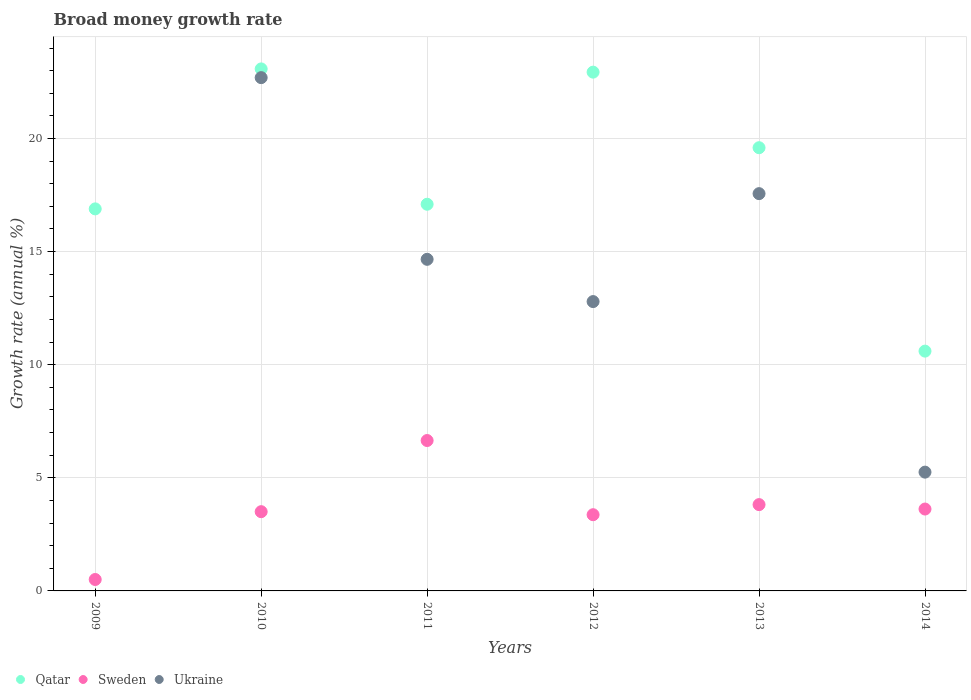What is the growth rate in Qatar in 2009?
Ensure brevity in your answer.  16.89. Across all years, what is the maximum growth rate in Sweden?
Keep it short and to the point. 6.65. Across all years, what is the minimum growth rate in Qatar?
Make the answer very short. 10.6. What is the total growth rate in Qatar in the graph?
Ensure brevity in your answer.  110.19. What is the difference between the growth rate in Sweden in 2010 and that in 2014?
Your response must be concise. -0.12. What is the difference between the growth rate in Ukraine in 2009 and the growth rate in Qatar in 2010?
Your response must be concise. -23.08. What is the average growth rate in Sweden per year?
Ensure brevity in your answer.  3.58. In the year 2010, what is the difference between the growth rate in Sweden and growth rate in Ukraine?
Your answer should be compact. -19.19. What is the ratio of the growth rate in Qatar in 2011 to that in 2013?
Your response must be concise. 0.87. What is the difference between the highest and the second highest growth rate in Qatar?
Your answer should be very brief. 0.14. What is the difference between the highest and the lowest growth rate in Qatar?
Ensure brevity in your answer.  12.48. In how many years, is the growth rate in Sweden greater than the average growth rate in Sweden taken over all years?
Your answer should be compact. 3. Is the sum of the growth rate in Sweden in 2010 and 2011 greater than the maximum growth rate in Ukraine across all years?
Offer a very short reply. No. Is the growth rate in Sweden strictly less than the growth rate in Ukraine over the years?
Ensure brevity in your answer.  No. Where does the legend appear in the graph?
Keep it short and to the point. Bottom left. How are the legend labels stacked?
Provide a short and direct response. Horizontal. What is the title of the graph?
Keep it short and to the point. Broad money growth rate. What is the label or title of the X-axis?
Ensure brevity in your answer.  Years. What is the label or title of the Y-axis?
Ensure brevity in your answer.  Growth rate (annual %). What is the Growth rate (annual %) of Qatar in 2009?
Offer a terse response. 16.89. What is the Growth rate (annual %) of Sweden in 2009?
Provide a short and direct response. 0.51. What is the Growth rate (annual %) in Qatar in 2010?
Provide a short and direct response. 23.08. What is the Growth rate (annual %) of Sweden in 2010?
Ensure brevity in your answer.  3.5. What is the Growth rate (annual %) in Ukraine in 2010?
Your response must be concise. 22.69. What is the Growth rate (annual %) in Qatar in 2011?
Your answer should be compact. 17.09. What is the Growth rate (annual %) in Sweden in 2011?
Provide a succinct answer. 6.65. What is the Growth rate (annual %) in Ukraine in 2011?
Your answer should be very brief. 14.66. What is the Growth rate (annual %) of Qatar in 2012?
Your response must be concise. 22.93. What is the Growth rate (annual %) in Sweden in 2012?
Your answer should be very brief. 3.37. What is the Growth rate (annual %) of Ukraine in 2012?
Provide a succinct answer. 12.79. What is the Growth rate (annual %) in Qatar in 2013?
Offer a terse response. 19.59. What is the Growth rate (annual %) in Sweden in 2013?
Your response must be concise. 3.82. What is the Growth rate (annual %) in Ukraine in 2013?
Your response must be concise. 17.56. What is the Growth rate (annual %) in Qatar in 2014?
Your response must be concise. 10.6. What is the Growth rate (annual %) of Sweden in 2014?
Ensure brevity in your answer.  3.62. What is the Growth rate (annual %) of Ukraine in 2014?
Provide a short and direct response. 5.25. Across all years, what is the maximum Growth rate (annual %) of Qatar?
Provide a short and direct response. 23.08. Across all years, what is the maximum Growth rate (annual %) in Sweden?
Make the answer very short. 6.65. Across all years, what is the maximum Growth rate (annual %) of Ukraine?
Offer a terse response. 22.69. Across all years, what is the minimum Growth rate (annual %) of Qatar?
Your answer should be very brief. 10.6. Across all years, what is the minimum Growth rate (annual %) in Sweden?
Your answer should be compact. 0.51. Across all years, what is the minimum Growth rate (annual %) of Ukraine?
Your answer should be very brief. 0. What is the total Growth rate (annual %) in Qatar in the graph?
Keep it short and to the point. 110.19. What is the total Growth rate (annual %) in Sweden in the graph?
Make the answer very short. 21.46. What is the total Growth rate (annual %) in Ukraine in the graph?
Ensure brevity in your answer.  72.96. What is the difference between the Growth rate (annual %) in Qatar in 2009 and that in 2010?
Keep it short and to the point. -6.19. What is the difference between the Growth rate (annual %) of Sweden in 2009 and that in 2010?
Your answer should be compact. -3. What is the difference between the Growth rate (annual %) of Qatar in 2009 and that in 2011?
Ensure brevity in your answer.  -0.2. What is the difference between the Growth rate (annual %) in Sweden in 2009 and that in 2011?
Your answer should be compact. -6.14. What is the difference between the Growth rate (annual %) of Qatar in 2009 and that in 2012?
Ensure brevity in your answer.  -6.04. What is the difference between the Growth rate (annual %) in Sweden in 2009 and that in 2012?
Keep it short and to the point. -2.86. What is the difference between the Growth rate (annual %) in Qatar in 2009 and that in 2013?
Make the answer very short. -2.7. What is the difference between the Growth rate (annual %) in Sweden in 2009 and that in 2013?
Offer a terse response. -3.31. What is the difference between the Growth rate (annual %) in Qatar in 2009 and that in 2014?
Provide a succinct answer. 6.29. What is the difference between the Growth rate (annual %) in Sweden in 2009 and that in 2014?
Your answer should be compact. -3.11. What is the difference between the Growth rate (annual %) in Qatar in 2010 and that in 2011?
Give a very brief answer. 5.98. What is the difference between the Growth rate (annual %) in Sweden in 2010 and that in 2011?
Provide a succinct answer. -3.15. What is the difference between the Growth rate (annual %) in Ukraine in 2010 and that in 2011?
Offer a very short reply. 8.03. What is the difference between the Growth rate (annual %) of Qatar in 2010 and that in 2012?
Offer a terse response. 0.14. What is the difference between the Growth rate (annual %) in Sweden in 2010 and that in 2012?
Make the answer very short. 0.13. What is the difference between the Growth rate (annual %) of Ukraine in 2010 and that in 2012?
Provide a succinct answer. 9.9. What is the difference between the Growth rate (annual %) in Qatar in 2010 and that in 2013?
Offer a terse response. 3.48. What is the difference between the Growth rate (annual %) of Sweden in 2010 and that in 2013?
Your answer should be compact. -0.31. What is the difference between the Growth rate (annual %) in Ukraine in 2010 and that in 2013?
Ensure brevity in your answer.  5.13. What is the difference between the Growth rate (annual %) of Qatar in 2010 and that in 2014?
Give a very brief answer. 12.48. What is the difference between the Growth rate (annual %) of Sweden in 2010 and that in 2014?
Your response must be concise. -0.12. What is the difference between the Growth rate (annual %) in Ukraine in 2010 and that in 2014?
Give a very brief answer. 17.44. What is the difference between the Growth rate (annual %) of Qatar in 2011 and that in 2012?
Give a very brief answer. -5.84. What is the difference between the Growth rate (annual %) of Sweden in 2011 and that in 2012?
Your response must be concise. 3.28. What is the difference between the Growth rate (annual %) of Ukraine in 2011 and that in 2012?
Your answer should be very brief. 1.87. What is the difference between the Growth rate (annual %) in Qatar in 2011 and that in 2013?
Keep it short and to the point. -2.5. What is the difference between the Growth rate (annual %) of Sweden in 2011 and that in 2013?
Offer a very short reply. 2.83. What is the difference between the Growth rate (annual %) in Ukraine in 2011 and that in 2013?
Your response must be concise. -2.9. What is the difference between the Growth rate (annual %) in Qatar in 2011 and that in 2014?
Offer a terse response. 6.49. What is the difference between the Growth rate (annual %) of Sweden in 2011 and that in 2014?
Your response must be concise. 3.03. What is the difference between the Growth rate (annual %) in Ukraine in 2011 and that in 2014?
Keep it short and to the point. 9.41. What is the difference between the Growth rate (annual %) in Qatar in 2012 and that in 2013?
Provide a succinct answer. 3.34. What is the difference between the Growth rate (annual %) in Sweden in 2012 and that in 2013?
Keep it short and to the point. -0.45. What is the difference between the Growth rate (annual %) of Ukraine in 2012 and that in 2013?
Ensure brevity in your answer.  -4.77. What is the difference between the Growth rate (annual %) of Qatar in 2012 and that in 2014?
Make the answer very short. 12.33. What is the difference between the Growth rate (annual %) of Sweden in 2012 and that in 2014?
Your response must be concise. -0.25. What is the difference between the Growth rate (annual %) in Ukraine in 2012 and that in 2014?
Provide a succinct answer. 7.54. What is the difference between the Growth rate (annual %) of Qatar in 2013 and that in 2014?
Give a very brief answer. 8.99. What is the difference between the Growth rate (annual %) of Sweden in 2013 and that in 2014?
Provide a succinct answer. 0.2. What is the difference between the Growth rate (annual %) of Ukraine in 2013 and that in 2014?
Your answer should be very brief. 12.31. What is the difference between the Growth rate (annual %) in Qatar in 2009 and the Growth rate (annual %) in Sweden in 2010?
Offer a terse response. 13.39. What is the difference between the Growth rate (annual %) of Qatar in 2009 and the Growth rate (annual %) of Ukraine in 2010?
Your answer should be very brief. -5.8. What is the difference between the Growth rate (annual %) of Sweden in 2009 and the Growth rate (annual %) of Ukraine in 2010?
Keep it short and to the point. -22.19. What is the difference between the Growth rate (annual %) of Qatar in 2009 and the Growth rate (annual %) of Sweden in 2011?
Provide a succinct answer. 10.24. What is the difference between the Growth rate (annual %) of Qatar in 2009 and the Growth rate (annual %) of Ukraine in 2011?
Give a very brief answer. 2.23. What is the difference between the Growth rate (annual %) in Sweden in 2009 and the Growth rate (annual %) in Ukraine in 2011?
Ensure brevity in your answer.  -14.15. What is the difference between the Growth rate (annual %) in Qatar in 2009 and the Growth rate (annual %) in Sweden in 2012?
Your answer should be very brief. 13.52. What is the difference between the Growth rate (annual %) in Qatar in 2009 and the Growth rate (annual %) in Ukraine in 2012?
Ensure brevity in your answer.  4.1. What is the difference between the Growth rate (annual %) of Sweden in 2009 and the Growth rate (annual %) of Ukraine in 2012?
Provide a succinct answer. -12.29. What is the difference between the Growth rate (annual %) in Qatar in 2009 and the Growth rate (annual %) in Sweden in 2013?
Offer a very short reply. 13.07. What is the difference between the Growth rate (annual %) in Qatar in 2009 and the Growth rate (annual %) in Ukraine in 2013?
Offer a very short reply. -0.67. What is the difference between the Growth rate (annual %) in Sweden in 2009 and the Growth rate (annual %) in Ukraine in 2013?
Keep it short and to the point. -17.06. What is the difference between the Growth rate (annual %) of Qatar in 2009 and the Growth rate (annual %) of Sweden in 2014?
Your answer should be compact. 13.27. What is the difference between the Growth rate (annual %) of Qatar in 2009 and the Growth rate (annual %) of Ukraine in 2014?
Provide a short and direct response. 11.64. What is the difference between the Growth rate (annual %) of Sweden in 2009 and the Growth rate (annual %) of Ukraine in 2014?
Offer a very short reply. -4.75. What is the difference between the Growth rate (annual %) of Qatar in 2010 and the Growth rate (annual %) of Sweden in 2011?
Offer a very short reply. 16.43. What is the difference between the Growth rate (annual %) of Qatar in 2010 and the Growth rate (annual %) of Ukraine in 2011?
Keep it short and to the point. 8.42. What is the difference between the Growth rate (annual %) in Sweden in 2010 and the Growth rate (annual %) in Ukraine in 2011?
Provide a short and direct response. -11.16. What is the difference between the Growth rate (annual %) in Qatar in 2010 and the Growth rate (annual %) in Sweden in 2012?
Provide a succinct answer. 19.71. What is the difference between the Growth rate (annual %) of Qatar in 2010 and the Growth rate (annual %) of Ukraine in 2012?
Your answer should be very brief. 10.29. What is the difference between the Growth rate (annual %) in Sweden in 2010 and the Growth rate (annual %) in Ukraine in 2012?
Ensure brevity in your answer.  -9.29. What is the difference between the Growth rate (annual %) in Qatar in 2010 and the Growth rate (annual %) in Sweden in 2013?
Offer a very short reply. 19.26. What is the difference between the Growth rate (annual %) in Qatar in 2010 and the Growth rate (annual %) in Ukraine in 2013?
Provide a succinct answer. 5.51. What is the difference between the Growth rate (annual %) of Sweden in 2010 and the Growth rate (annual %) of Ukraine in 2013?
Ensure brevity in your answer.  -14.06. What is the difference between the Growth rate (annual %) in Qatar in 2010 and the Growth rate (annual %) in Sweden in 2014?
Offer a terse response. 19.46. What is the difference between the Growth rate (annual %) of Qatar in 2010 and the Growth rate (annual %) of Ukraine in 2014?
Keep it short and to the point. 17.83. What is the difference between the Growth rate (annual %) of Sweden in 2010 and the Growth rate (annual %) of Ukraine in 2014?
Your answer should be very brief. -1.75. What is the difference between the Growth rate (annual %) in Qatar in 2011 and the Growth rate (annual %) in Sweden in 2012?
Your response must be concise. 13.72. What is the difference between the Growth rate (annual %) of Qatar in 2011 and the Growth rate (annual %) of Ukraine in 2012?
Your answer should be compact. 4.3. What is the difference between the Growth rate (annual %) of Sweden in 2011 and the Growth rate (annual %) of Ukraine in 2012?
Keep it short and to the point. -6.14. What is the difference between the Growth rate (annual %) of Qatar in 2011 and the Growth rate (annual %) of Sweden in 2013?
Provide a succinct answer. 13.28. What is the difference between the Growth rate (annual %) in Qatar in 2011 and the Growth rate (annual %) in Ukraine in 2013?
Your answer should be very brief. -0.47. What is the difference between the Growth rate (annual %) of Sweden in 2011 and the Growth rate (annual %) of Ukraine in 2013?
Your answer should be very brief. -10.91. What is the difference between the Growth rate (annual %) in Qatar in 2011 and the Growth rate (annual %) in Sweden in 2014?
Provide a succinct answer. 13.47. What is the difference between the Growth rate (annual %) of Qatar in 2011 and the Growth rate (annual %) of Ukraine in 2014?
Your answer should be very brief. 11.84. What is the difference between the Growth rate (annual %) in Sweden in 2011 and the Growth rate (annual %) in Ukraine in 2014?
Give a very brief answer. 1.4. What is the difference between the Growth rate (annual %) of Qatar in 2012 and the Growth rate (annual %) of Sweden in 2013?
Make the answer very short. 19.12. What is the difference between the Growth rate (annual %) in Qatar in 2012 and the Growth rate (annual %) in Ukraine in 2013?
Make the answer very short. 5.37. What is the difference between the Growth rate (annual %) of Sweden in 2012 and the Growth rate (annual %) of Ukraine in 2013?
Your response must be concise. -14.19. What is the difference between the Growth rate (annual %) of Qatar in 2012 and the Growth rate (annual %) of Sweden in 2014?
Keep it short and to the point. 19.31. What is the difference between the Growth rate (annual %) in Qatar in 2012 and the Growth rate (annual %) in Ukraine in 2014?
Offer a very short reply. 17.68. What is the difference between the Growth rate (annual %) of Sweden in 2012 and the Growth rate (annual %) of Ukraine in 2014?
Your answer should be very brief. -1.88. What is the difference between the Growth rate (annual %) in Qatar in 2013 and the Growth rate (annual %) in Sweden in 2014?
Keep it short and to the point. 15.97. What is the difference between the Growth rate (annual %) in Qatar in 2013 and the Growth rate (annual %) in Ukraine in 2014?
Offer a very short reply. 14.34. What is the difference between the Growth rate (annual %) of Sweden in 2013 and the Growth rate (annual %) of Ukraine in 2014?
Offer a terse response. -1.44. What is the average Growth rate (annual %) of Qatar per year?
Provide a succinct answer. 18.36. What is the average Growth rate (annual %) in Sweden per year?
Ensure brevity in your answer.  3.58. What is the average Growth rate (annual %) in Ukraine per year?
Offer a very short reply. 12.16. In the year 2009, what is the difference between the Growth rate (annual %) in Qatar and Growth rate (annual %) in Sweden?
Provide a succinct answer. 16.38. In the year 2010, what is the difference between the Growth rate (annual %) of Qatar and Growth rate (annual %) of Sweden?
Keep it short and to the point. 19.57. In the year 2010, what is the difference between the Growth rate (annual %) of Qatar and Growth rate (annual %) of Ukraine?
Keep it short and to the point. 0.39. In the year 2010, what is the difference between the Growth rate (annual %) in Sweden and Growth rate (annual %) in Ukraine?
Make the answer very short. -19.19. In the year 2011, what is the difference between the Growth rate (annual %) in Qatar and Growth rate (annual %) in Sweden?
Give a very brief answer. 10.45. In the year 2011, what is the difference between the Growth rate (annual %) of Qatar and Growth rate (annual %) of Ukraine?
Make the answer very short. 2.43. In the year 2011, what is the difference between the Growth rate (annual %) in Sweden and Growth rate (annual %) in Ukraine?
Keep it short and to the point. -8.01. In the year 2012, what is the difference between the Growth rate (annual %) of Qatar and Growth rate (annual %) of Sweden?
Offer a very short reply. 19.57. In the year 2012, what is the difference between the Growth rate (annual %) in Qatar and Growth rate (annual %) in Ukraine?
Offer a very short reply. 10.14. In the year 2012, what is the difference between the Growth rate (annual %) in Sweden and Growth rate (annual %) in Ukraine?
Offer a terse response. -9.42. In the year 2013, what is the difference between the Growth rate (annual %) of Qatar and Growth rate (annual %) of Sweden?
Keep it short and to the point. 15.78. In the year 2013, what is the difference between the Growth rate (annual %) of Qatar and Growth rate (annual %) of Ukraine?
Keep it short and to the point. 2.03. In the year 2013, what is the difference between the Growth rate (annual %) of Sweden and Growth rate (annual %) of Ukraine?
Your answer should be compact. -13.75. In the year 2014, what is the difference between the Growth rate (annual %) in Qatar and Growth rate (annual %) in Sweden?
Your answer should be compact. 6.98. In the year 2014, what is the difference between the Growth rate (annual %) of Qatar and Growth rate (annual %) of Ukraine?
Give a very brief answer. 5.35. In the year 2014, what is the difference between the Growth rate (annual %) of Sweden and Growth rate (annual %) of Ukraine?
Give a very brief answer. -1.63. What is the ratio of the Growth rate (annual %) in Qatar in 2009 to that in 2010?
Make the answer very short. 0.73. What is the ratio of the Growth rate (annual %) in Sweden in 2009 to that in 2010?
Your response must be concise. 0.14. What is the ratio of the Growth rate (annual %) in Sweden in 2009 to that in 2011?
Your answer should be very brief. 0.08. What is the ratio of the Growth rate (annual %) in Qatar in 2009 to that in 2012?
Your answer should be compact. 0.74. What is the ratio of the Growth rate (annual %) of Sweden in 2009 to that in 2012?
Your response must be concise. 0.15. What is the ratio of the Growth rate (annual %) in Qatar in 2009 to that in 2013?
Keep it short and to the point. 0.86. What is the ratio of the Growth rate (annual %) in Sweden in 2009 to that in 2013?
Provide a succinct answer. 0.13. What is the ratio of the Growth rate (annual %) in Qatar in 2009 to that in 2014?
Provide a short and direct response. 1.59. What is the ratio of the Growth rate (annual %) in Sweden in 2009 to that in 2014?
Your answer should be very brief. 0.14. What is the ratio of the Growth rate (annual %) of Qatar in 2010 to that in 2011?
Make the answer very short. 1.35. What is the ratio of the Growth rate (annual %) of Sweden in 2010 to that in 2011?
Your answer should be very brief. 0.53. What is the ratio of the Growth rate (annual %) in Ukraine in 2010 to that in 2011?
Your response must be concise. 1.55. What is the ratio of the Growth rate (annual %) of Qatar in 2010 to that in 2012?
Your answer should be very brief. 1.01. What is the ratio of the Growth rate (annual %) in Sweden in 2010 to that in 2012?
Offer a very short reply. 1.04. What is the ratio of the Growth rate (annual %) of Ukraine in 2010 to that in 2012?
Keep it short and to the point. 1.77. What is the ratio of the Growth rate (annual %) in Qatar in 2010 to that in 2013?
Give a very brief answer. 1.18. What is the ratio of the Growth rate (annual %) of Sweden in 2010 to that in 2013?
Your response must be concise. 0.92. What is the ratio of the Growth rate (annual %) in Ukraine in 2010 to that in 2013?
Your answer should be very brief. 1.29. What is the ratio of the Growth rate (annual %) of Qatar in 2010 to that in 2014?
Your answer should be compact. 2.18. What is the ratio of the Growth rate (annual %) in Sweden in 2010 to that in 2014?
Your response must be concise. 0.97. What is the ratio of the Growth rate (annual %) of Ukraine in 2010 to that in 2014?
Provide a succinct answer. 4.32. What is the ratio of the Growth rate (annual %) in Qatar in 2011 to that in 2012?
Ensure brevity in your answer.  0.75. What is the ratio of the Growth rate (annual %) in Sweden in 2011 to that in 2012?
Keep it short and to the point. 1.97. What is the ratio of the Growth rate (annual %) in Ukraine in 2011 to that in 2012?
Offer a very short reply. 1.15. What is the ratio of the Growth rate (annual %) of Qatar in 2011 to that in 2013?
Provide a short and direct response. 0.87. What is the ratio of the Growth rate (annual %) in Sweden in 2011 to that in 2013?
Offer a terse response. 1.74. What is the ratio of the Growth rate (annual %) in Ukraine in 2011 to that in 2013?
Your answer should be very brief. 0.83. What is the ratio of the Growth rate (annual %) of Qatar in 2011 to that in 2014?
Offer a very short reply. 1.61. What is the ratio of the Growth rate (annual %) in Sweden in 2011 to that in 2014?
Your answer should be compact. 1.84. What is the ratio of the Growth rate (annual %) of Ukraine in 2011 to that in 2014?
Ensure brevity in your answer.  2.79. What is the ratio of the Growth rate (annual %) of Qatar in 2012 to that in 2013?
Your response must be concise. 1.17. What is the ratio of the Growth rate (annual %) of Sweden in 2012 to that in 2013?
Provide a short and direct response. 0.88. What is the ratio of the Growth rate (annual %) in Ukraine in 2012 to that in 2013?
Keep it short and to the point. 0.73. What is the ratio of the Growth rate (annual %) in Qatar in 2012 to that in 2014?
Your answer should be compact. 2.16. What is the ratio of the Growth rate (annual %) of Sweden in 2012 to that in 2014?
Provide a short and direct response. 0.93. What is the ratio of the Growth rate (annual %) of Ukraine in 2012 to that in 2014?
Ensure brevity in your answer.  2.44. What is the ratio of the Growth rate (annual %) in Qatar in 2013 to that in 2014?
Ensure brevity in your answer.  1.85. What is the ratio of the Growth rate (annual %) in Sweden in 2013 to that in 2014?
Offer a terse response. 1.05. What is the ratio of the Growth rate (annual %) in Ukraine in 2013 to that in 2014?
Keep it short and to the point. 3.34. What is the difference between the highest and the second highest Growth rate (annual %) of Qatar?
Make the answer very short. 0.14. What is the difference between the highest and the second highest Growth rate (annual %) of Sweden?
Provide a succinct answer. 2.83. What is the difference between the highest and the second highest Growth rate (annual %) in Ukraine?
Your response must be concise. 5.13. What is the difference between the highest and the lowest Growth rate (annual %) in Qatar?
Your response must be concise. 12.48. What is the difference between the highest and the lowest Growth rate (annual %) in Sweden?
Your response must be concise. 6.14. What is the difference between the highest and the lowest Growth rate (annual %) in Ukraine?
Make the answer very short. 22.69. 